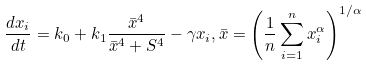<formula> <loc_0><loc_0><loc_500><loc_500>\frac { d x _ { i } } { d t } = k _ { 0 } + k _ { 1 } \frac { \bar { x } ^ { 4 } } { \bar { x } ^ { 4 } + S ^ { 4 } } - \gamma x _ { i } , \bar { x } = \left ( \frac { 1 } { n } \sum _ { i = 1 } ^ { n } x _ { i } ^ { \alpha } \right ) ^ { 1 / \alpha }</formula> 